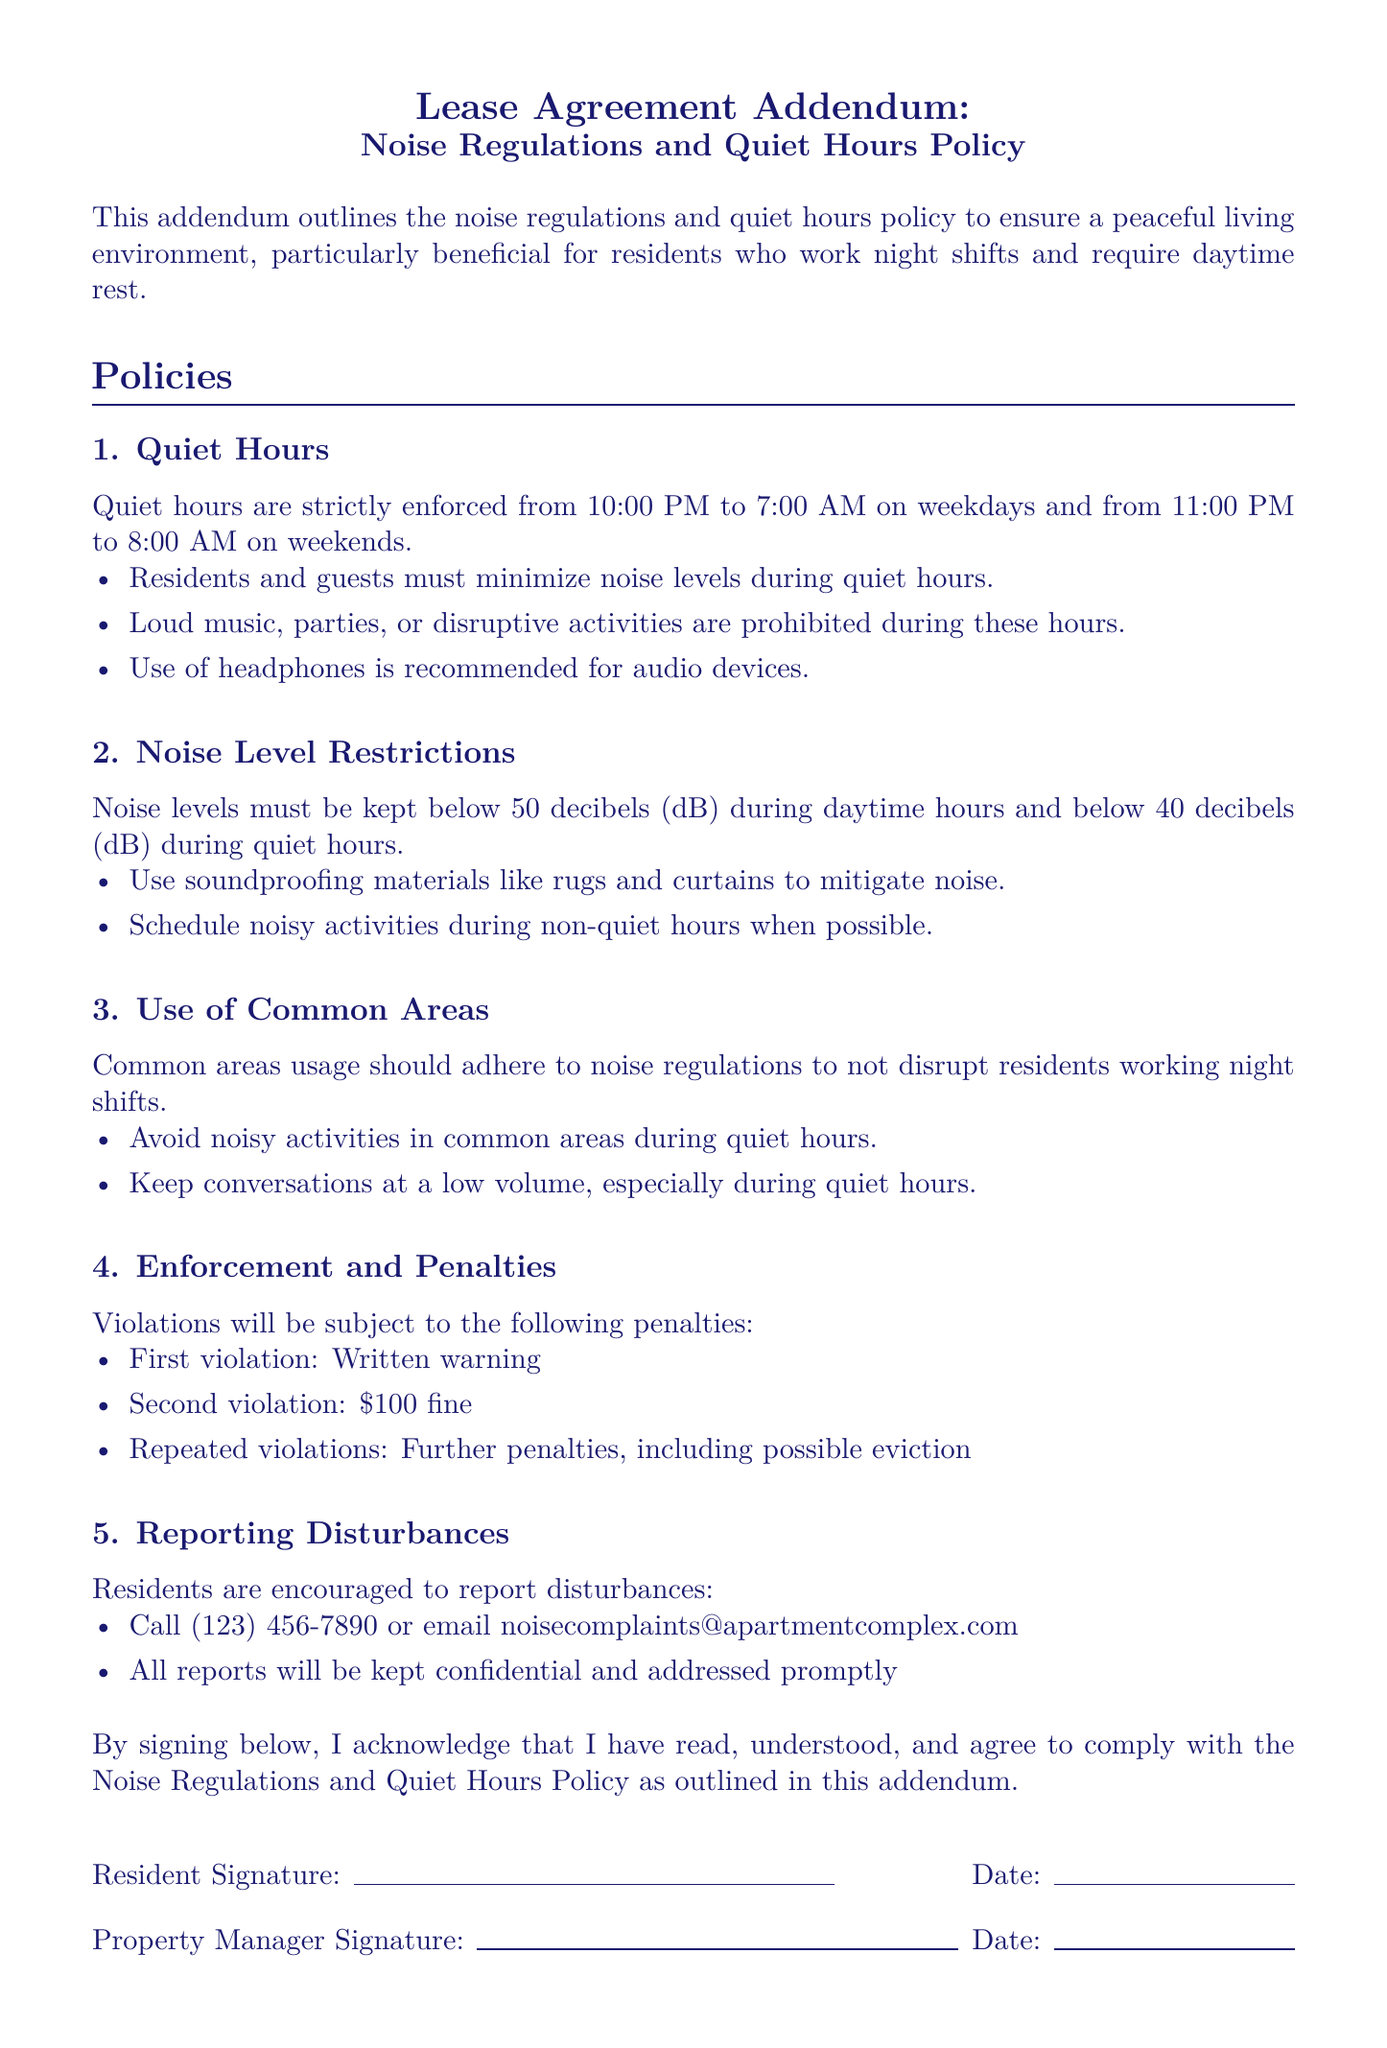What are the quiet hours on weekdays? The quiet hours on weekdays are strictly enforced from 10:00 PM to 7:00 AM.
Answer: 10:00 PM to 7:00 AM What is the maximum allowable noise level during quiet hours? The maximum allowable noise level during quiet hours is stated to be below 40 decibels.
Answer: below 40 decibels What action is recommended for audio devices? The document recommends the use of headphones for audio devices.
Answer: use of headphones What is the penalty for a second violation of the noise regulations? The penalty for a second violation is a fine of $100.
Answer: $100 fine What should residents avoid in common areas during quiet hours? Residents should avoid noisy activities in common areas during quiet hours.
Answer: noisy activities What is the contact number to report disturbances? The contact number provided to report disturbances is (123) 456-7890.
Answer: (123) 456-7890 What time do quiet hours start on weekends? Quiet hours on weekends start at 11:00 PM.
Answer: 11:00 PM How may residents keep conversations during quiet hours? Residents are instructed to keep conversations at a low volume, especially during quiet hours.
Answer: at a low volume 